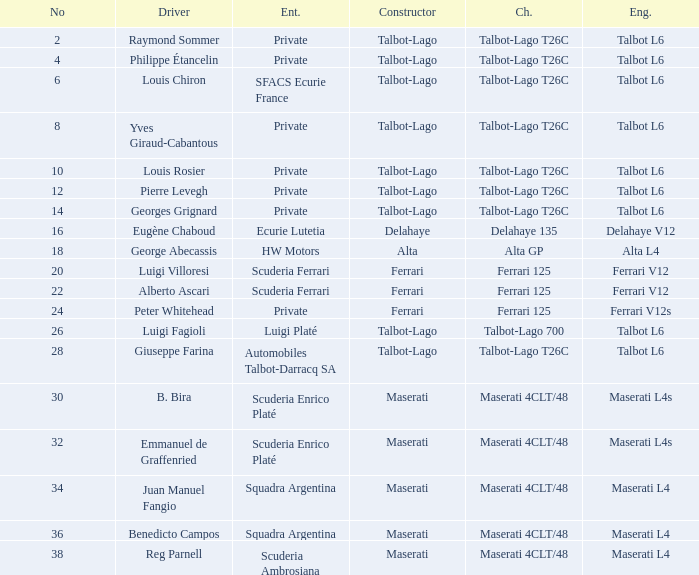Name the engine for ecurie lutetia Delahaye V12. 